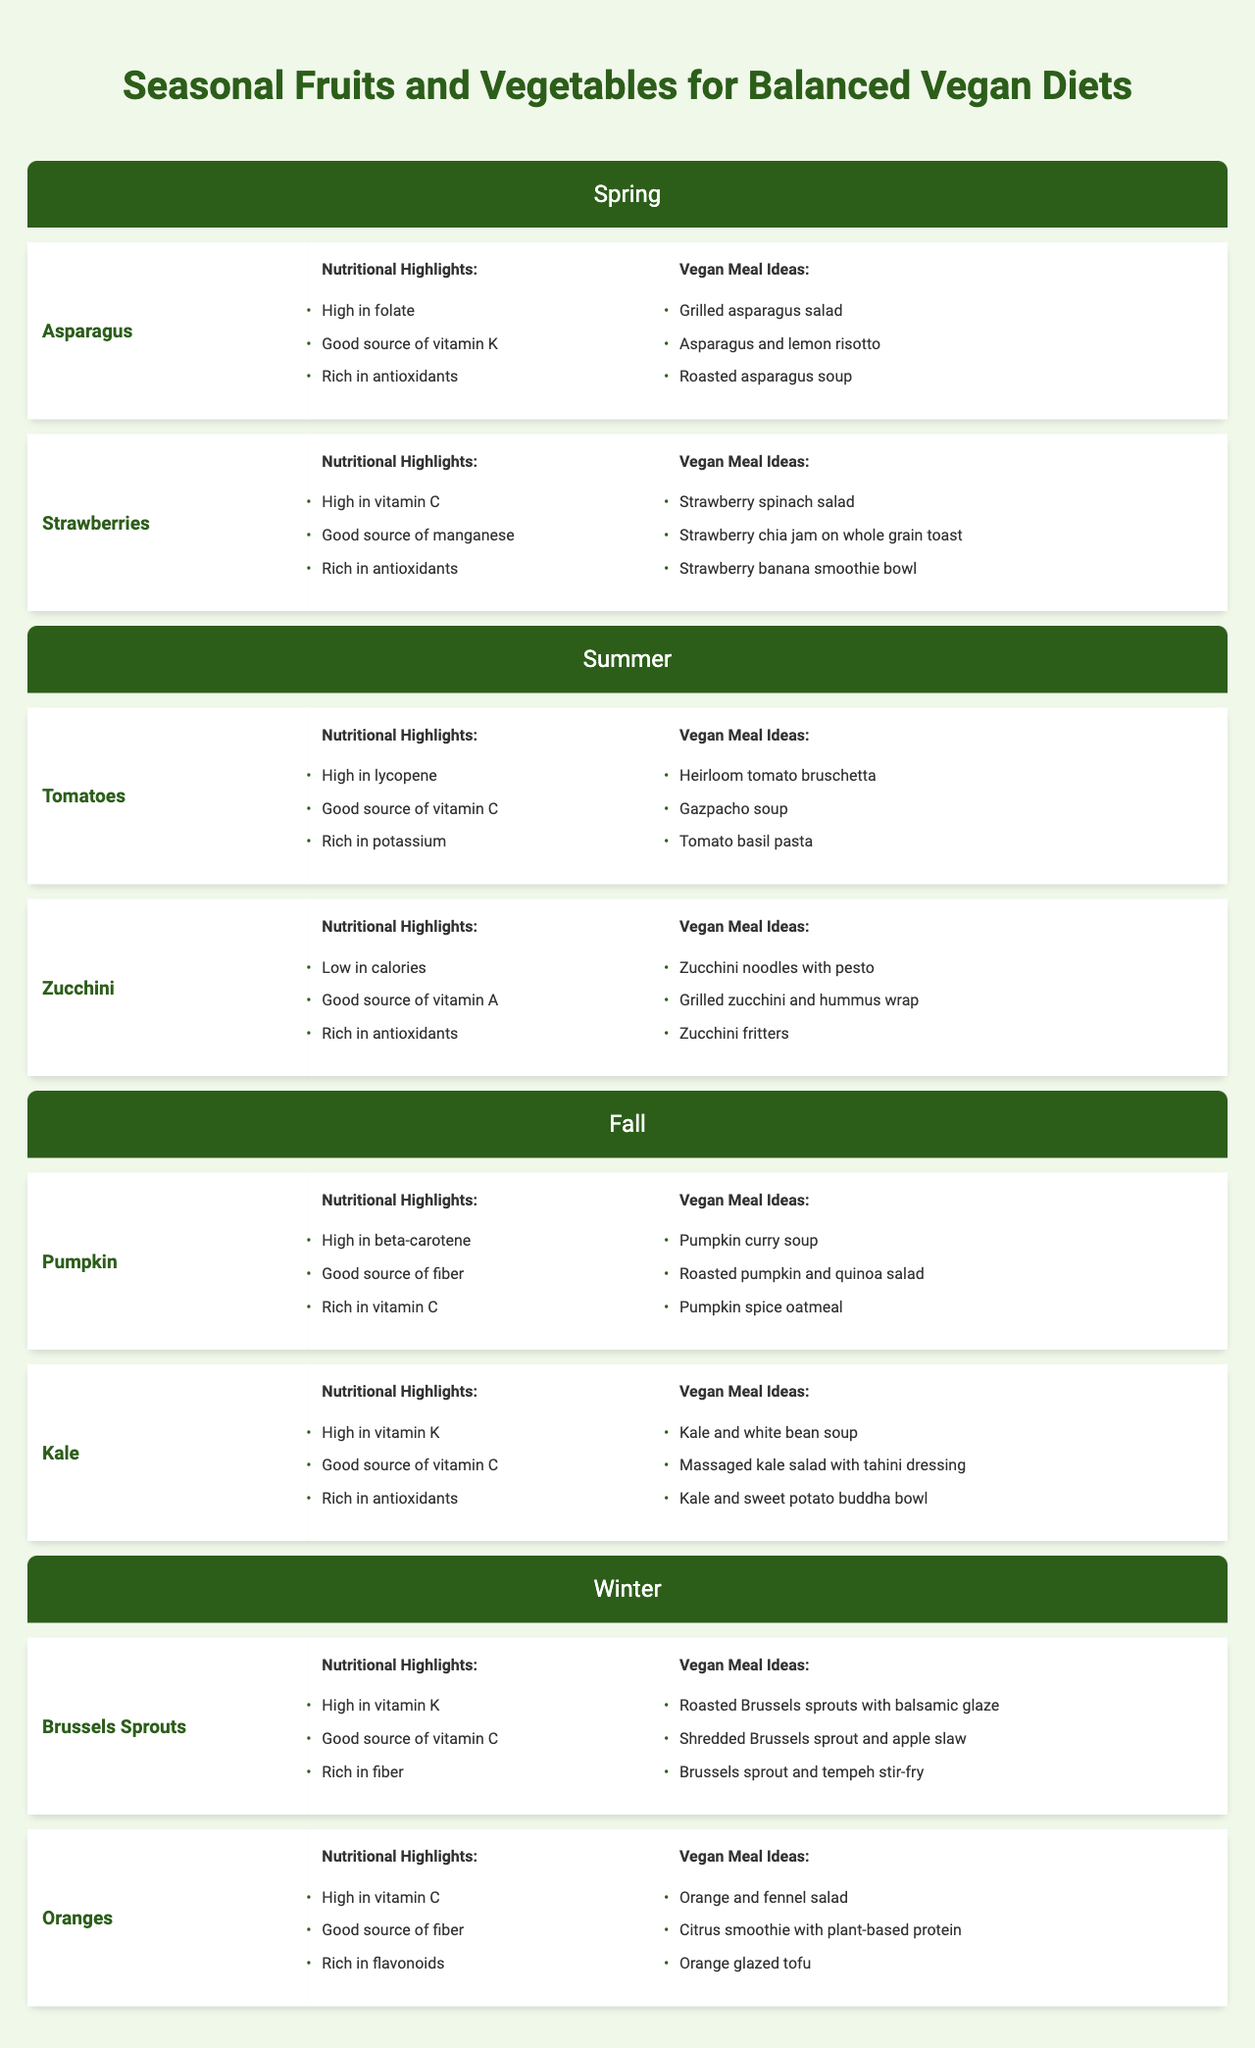What are the nutritional highlights of kale? Kale is listed under the Fall season in the table, and its nutritional highlights are specified as high in vitamin K, a good source of vitamin C, and rich in antioxidants.
Answer: High in vitamin K, good source of vitamin C, rich in antioxidants Which vegan meal idea is associated with strawberries? Strawberries are mentioned under the Spring season, and one of the vegan meal ideas listed is "Strawberry spinach salad."
Answer: Strawberry spinach salad Is pumpkin high in beta-carotene? The table lists pumpkin under the Fall season, and it states that pumpkin is high in beta-carotene.
Answer: Yes How many different fruits and vegetables are listed for the Winter season? The Winter season features two items: Brussels sprouts and oranges. Therefore, the total is 2 different fruits and vegetables.
Answer: 2 Which season features tomatoes and zucchinis? The table presents tomatoes and zucchinis under the Summer season.
Answer: Summer Do all seasonal vegetables mentioned have high vitamin C content? By examining the table, we can see that among the seasonal vegetables, strawberries, kale, Brussels sprouts, and oranges are high in vitamin C, while only some have this highlight.
Answer: No What is the total number of vegan meal ideas listed for asparagus? The vegan meal ideas for asparagus include three options: Grilled asparagus salad, Asparagus and lemon risotto, and Roasted asparagus soup, resulting in a total of 3 meal ideas.
Answer: 3 Which fruit has the highest concentration of vitamin C according to the table? From the table, both strawberries and oranges are indicated as high in vitamin C; however, oranges explicitly state it as a highlight. Since both are high in vitamin C, and no further explanation is provided, we cannot determine which is higher.
Answer: Cannot determine What alternative dish can be made using zucchinis besides zucchini noodles? The table lists alternatives for zucchinis, including "Grilled zucchini and hummus wrap" and "Zucchini fritters," indicating there are multiple options. The non-noodle option given as an example is "Grilled zucchini and hummus wrap."
Answer: Grilled zucchini and hummus wrap Compare the number of nutritional highlights for tomatoes and oranges. The table states that tomatoes have three nutritional highlights (high in lycopene, good source of vitamin C, rich in potassium) while oranges have three highlights (high in vitamin C, good source of fiber, rich in flavonoids). Both produce have the same number.
Answer: Same number (3 each) 